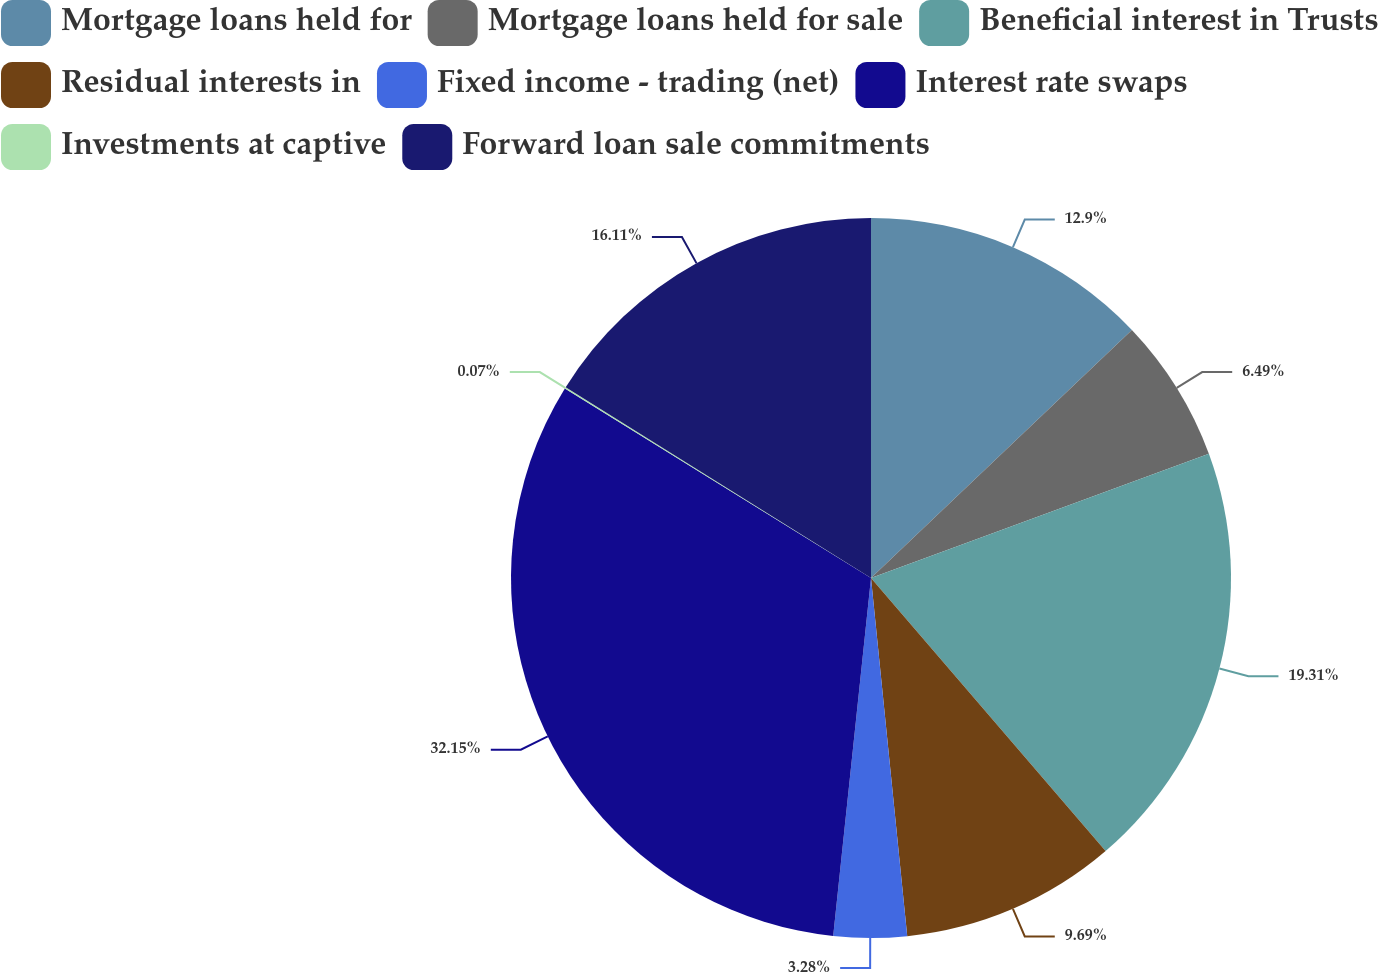Convert chart. <chart><loc_0><loc_0><loc_500><loc_500><pie_chart><fcel>Mortgage loans held for<fcel>Mortgage loans held for sale<fcel>Beneficial interest in Trusts<fcel>Residual interests in<fcel>Fixed income - trading (net)<fcel>Interest rate swaps<fcel>Investments at captive<fcel>Forward loan sale commitments<nl><fcel>12.9%<fcel>6.49%<fcel>19.31%<fcel>9.69%<fcel>3.28%<fcel>32.14%<fcel>0.07%<fcel>16.11%<nl></chart> 